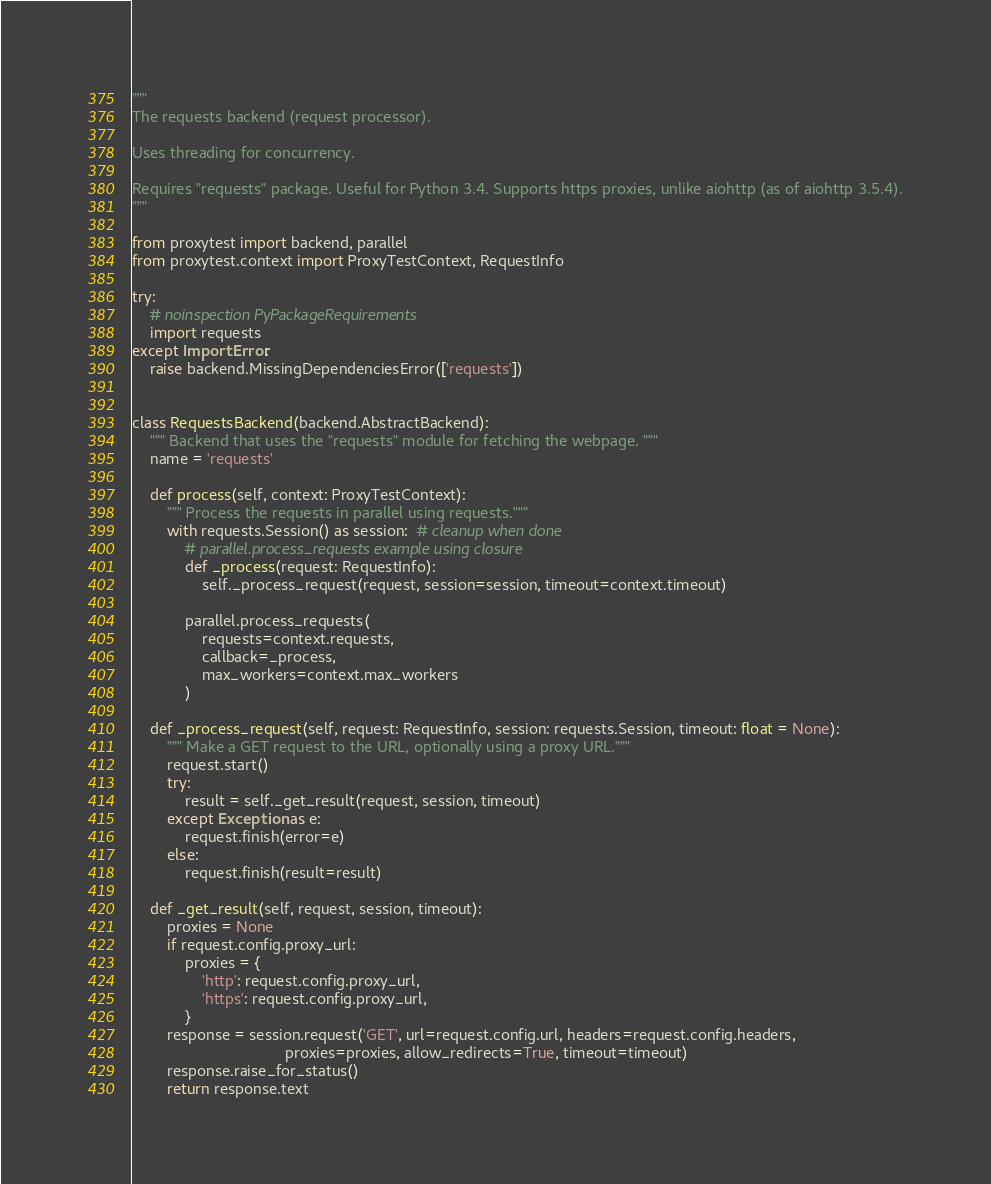Convert code to text. <code><loc_0><loc_0><loc_500><loc_500><_Python_>"""
The requests backend (request processor).

Uses threading for concurrency.

Requires "requests" package. Useful for Python 3.4. Supports https proxies, unlike aiohttp (as of aiohttp 3.5.4).
"""

from proxytest import backend, parallel
from proxytest.context import ProxyTestContext, RequestInfo

try:
    # noinspection PyPackageRequirements
    import requests
except ImportError:
    raise backend.MissingDependenciesError(['requests'])


class RequestsBackend(backend.AbstractBackend):
    """ Backend that uses the "requests" module for fetching the webpage. """
    name = 'requests'

    def process(self, context: ProxyTestContext):
        """ Process the requests in parallel using requests."""
        with requests.Session() as session:  # cleanup when done
            # parallel.process_requests example using closure
            def _process(request: RequestInfo):
                self._process_request(request, session=session, timeout=context.timeout)

            parallel.process_requests(
                requests=context.requests,
                callback=_process,
                max_workers=context.max_workers
            )

    def _process_request(self, request: RequestInfo, session: requests.Session, timeout: float = None):
        """ Make a GET request to the URL, optionally using a proxy URL."""
        request.start()
        try:
            result = self._get_result(request, session, timeout)
        except Exception as e:
            request.finish(error=e)
        else:
            request.finish(result=result)

    def _get_result(self, request, session, timeout):
        proxies = None
        if request.config.proxy_url:
            proxies = {
                'http': request.config.proxy_url,
                'https': request.config.proxy_url,
            }
        response = session.request('GET', url=request.config.url, headers=request.config.headers,
                                   proxies=proxies, allow_redirects=True, timeout=timeout)
        response.raise_for_status()
        return response.text
</code> 